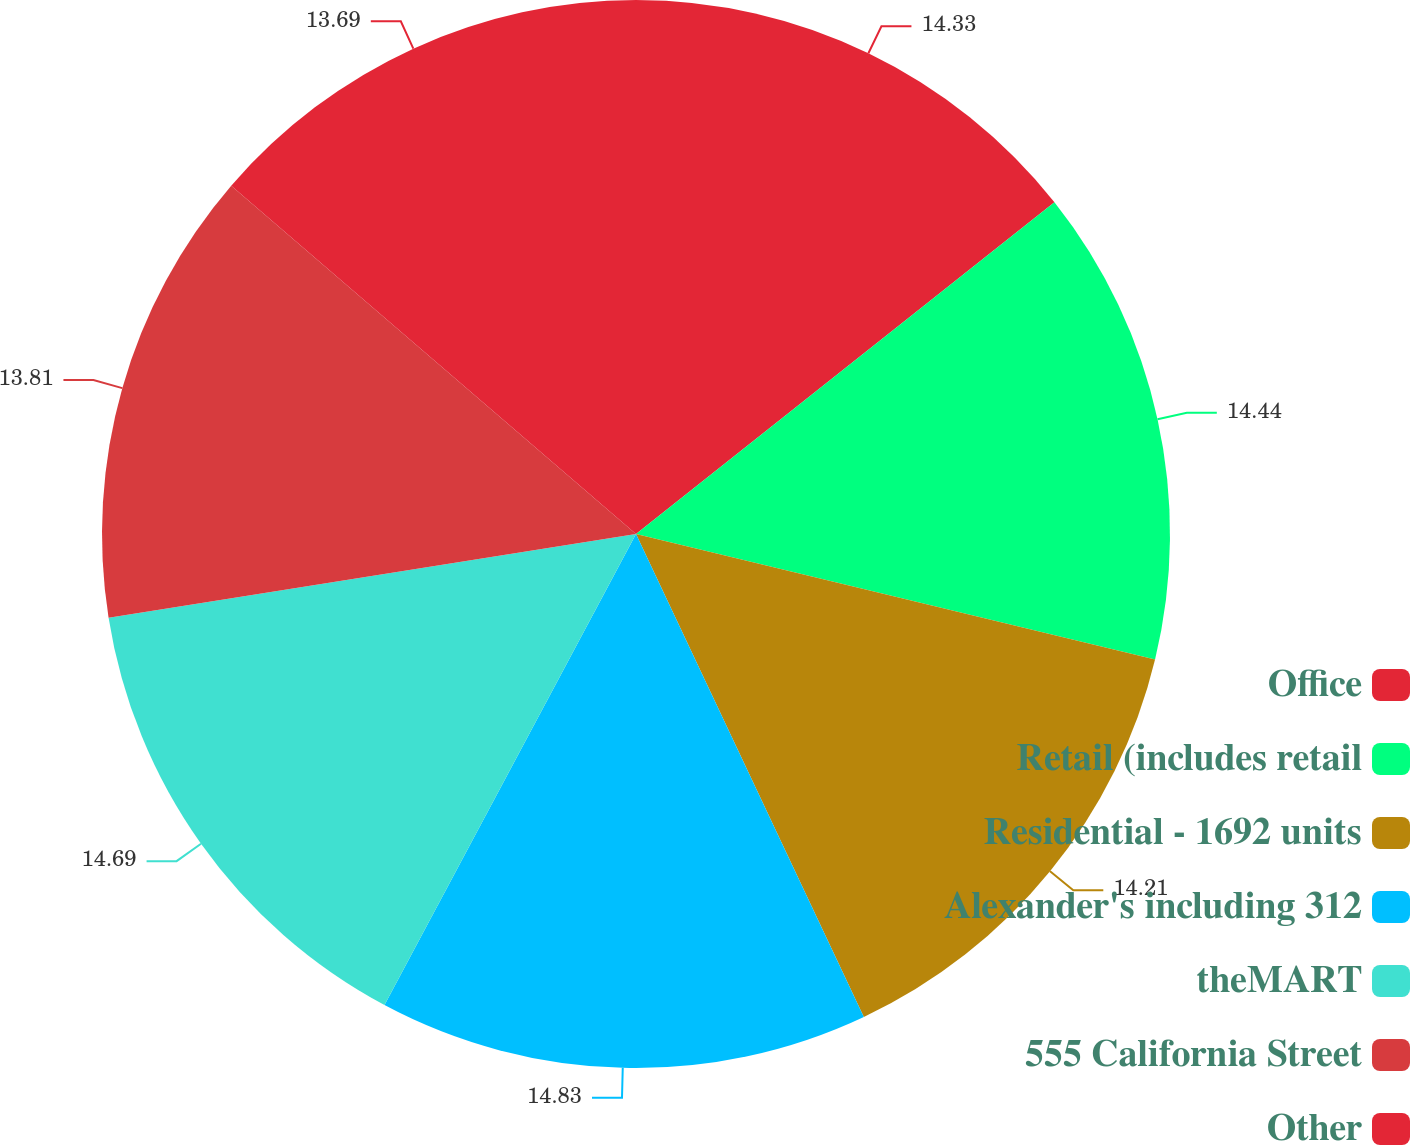Convert chart. <chart><loc_0><loc_0><loc_500><loc_500><pie_chart><fcel>Office<fcel>Retail (includes retail<fcel>Residential - 1692 units<fcel>Alexander's including 312<fcel>theMART<fcel>555 California Street<fcel>Other<nl><fcel>14.33%<fcel>14.44%<fcel>14.21%<fcel>14.82%<fcel>14.69%<fcel>13.81%<fcel>13.69%<nl></chart> 